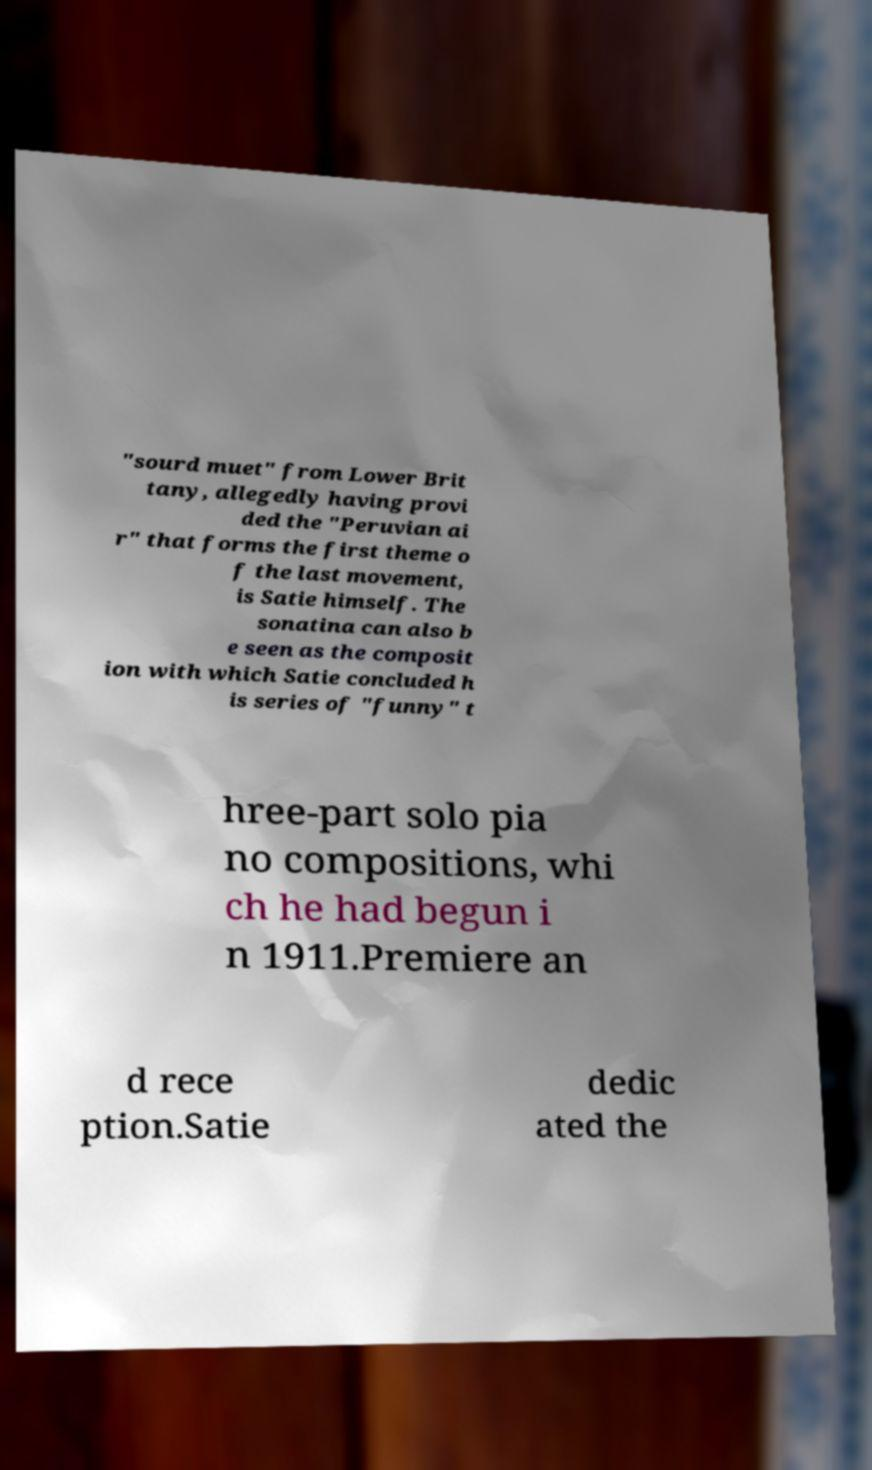There's text embedded in this image that I need extracted. Can you transcribe it verbatim? "sourd muet" from Lower Brit tany, allegedly having provi ded the "Peruvian ai r" that forms the first theme o f the last movement, is Satie himself. The sonatina can also b e seen as the composit ion with which Satie concluded h is series of "funny" t hree-part solo pia no compositions, whi ch he had begun i n 1911.Premiere an d rece ption.Satie dedic ated the 